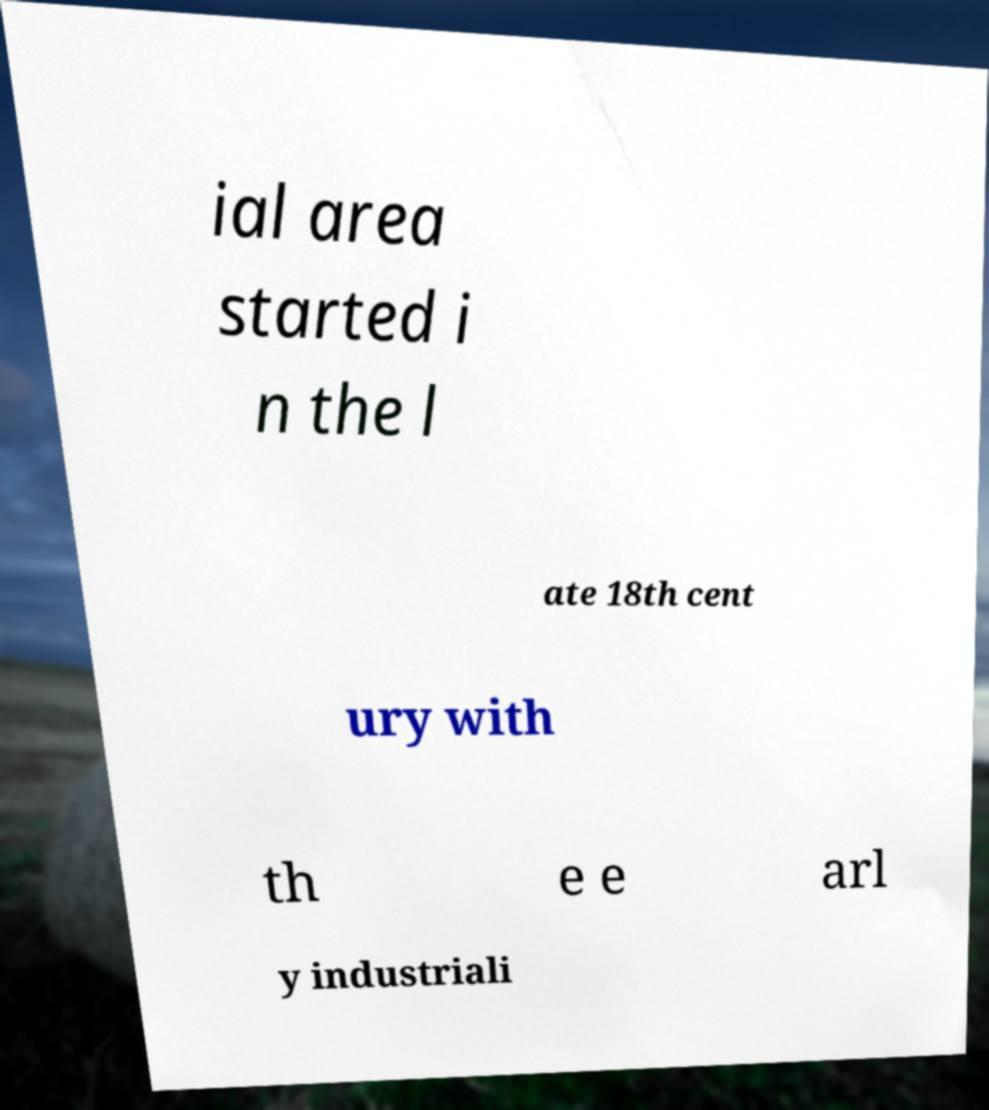Could you extract and type out the text from this image? ial area started i n the l ate 18th cent ury with th e e arl y industriali 